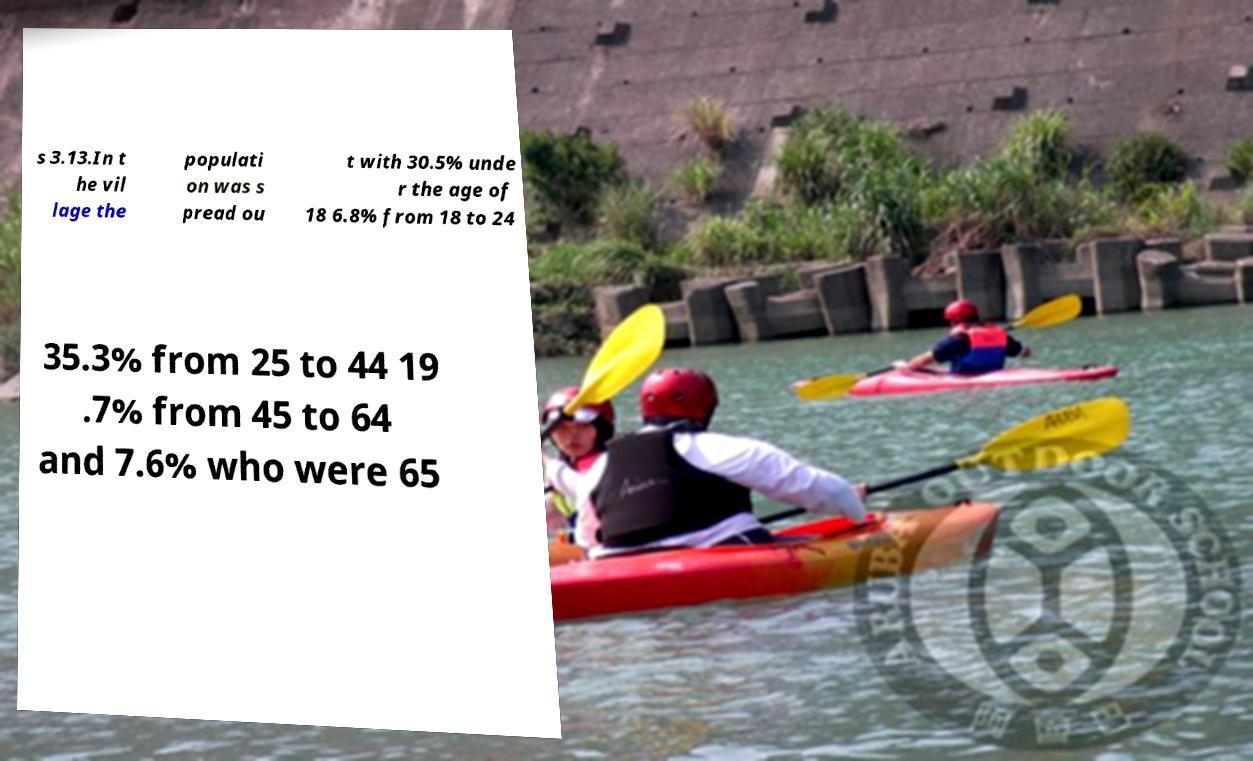Can you read and provide the text displayed in the image?This photo seems to have some interesting text. Can you extract and type it out for me? s 3.13.In t he vil lage the populati on was s pread ou t with 30.5% unde r the age of 18 6.8% from 18 to 24 35.3% from 25 to 44 19 .7% from 45 to 64 and 7.6% who were 65 